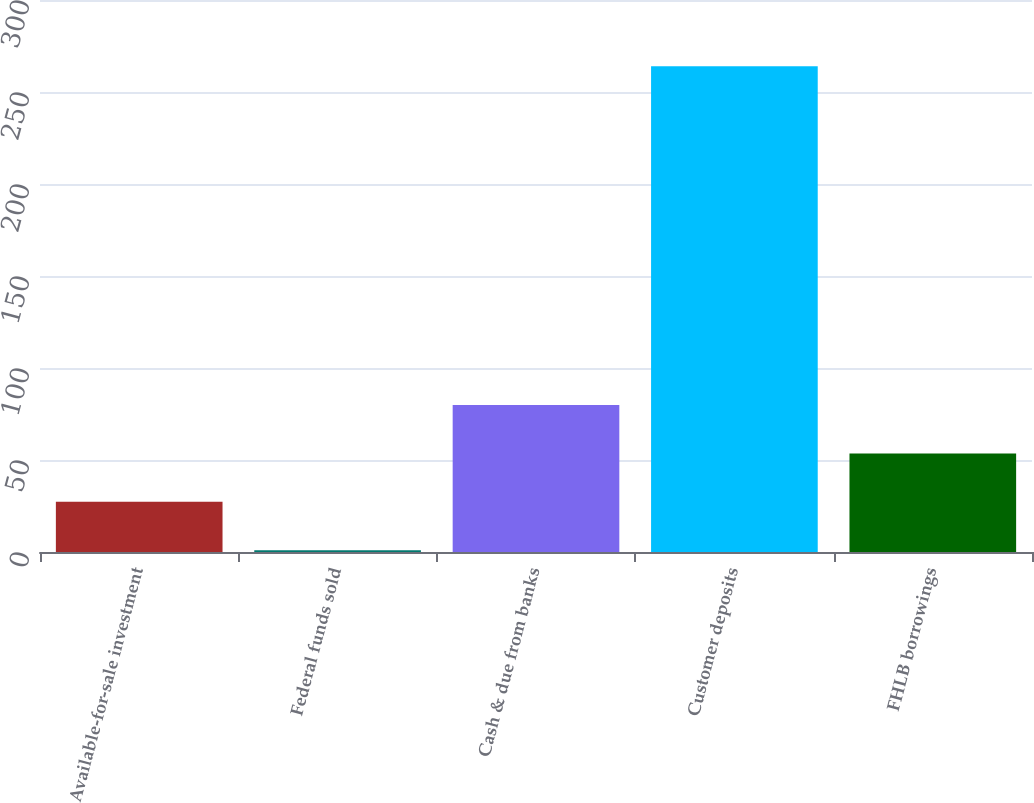Convert chart. <chart><loc_0><loc_0><loc_500><loc_500><bar_chart><fcel>Available-for-sale investment<fcel>Federal funds sold<fcel>Cash & due from banks<fcel>Customer deposits<fcel>FHLB borrowings<nl><fcel>27.3<fcel>1<fcel>79.9<fcel>264<fcel>53.6<nl></chart> 